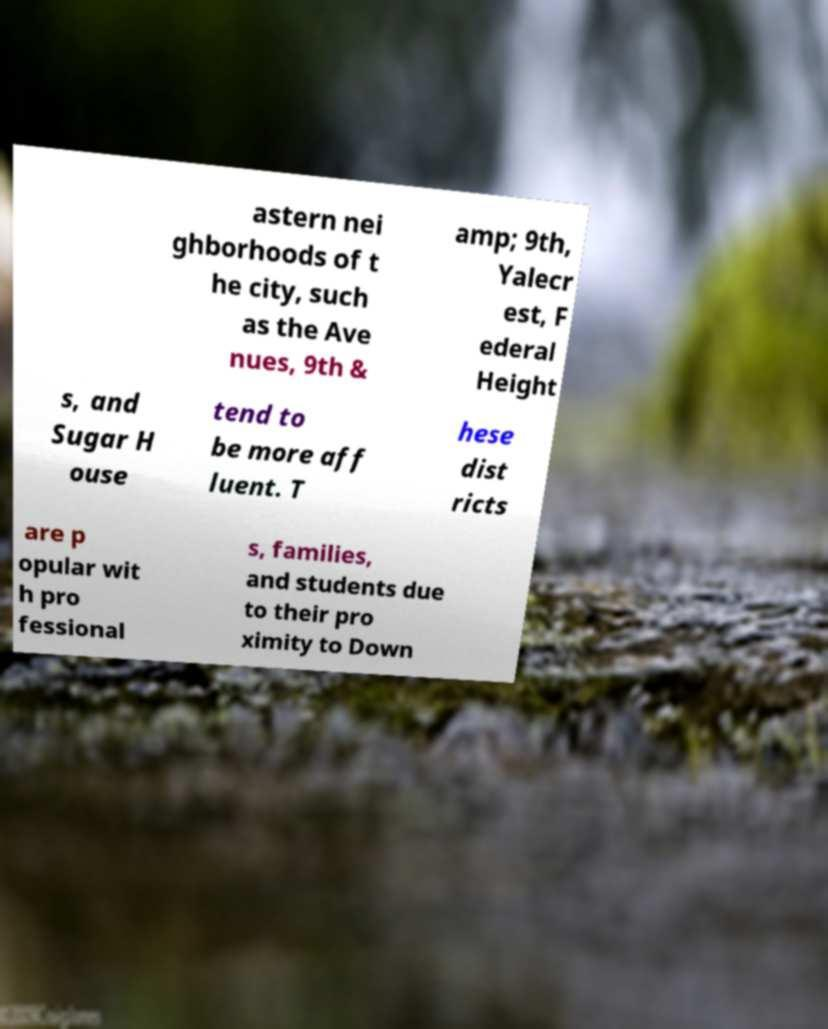Can you read and provide the text displayed in the image?This photo seems to have some interesting text. Can you extract and type it out for me? astern nei ghborhoods of t he city, such as the Ave nues, 9th & amp; 9th, Yalecr est, F ederal Height s, and Sugar H ouse tend to be more aff luent. T hese dist ricts are p opular wit h pro fessional s, families, and students due to their pro ximity to Down 